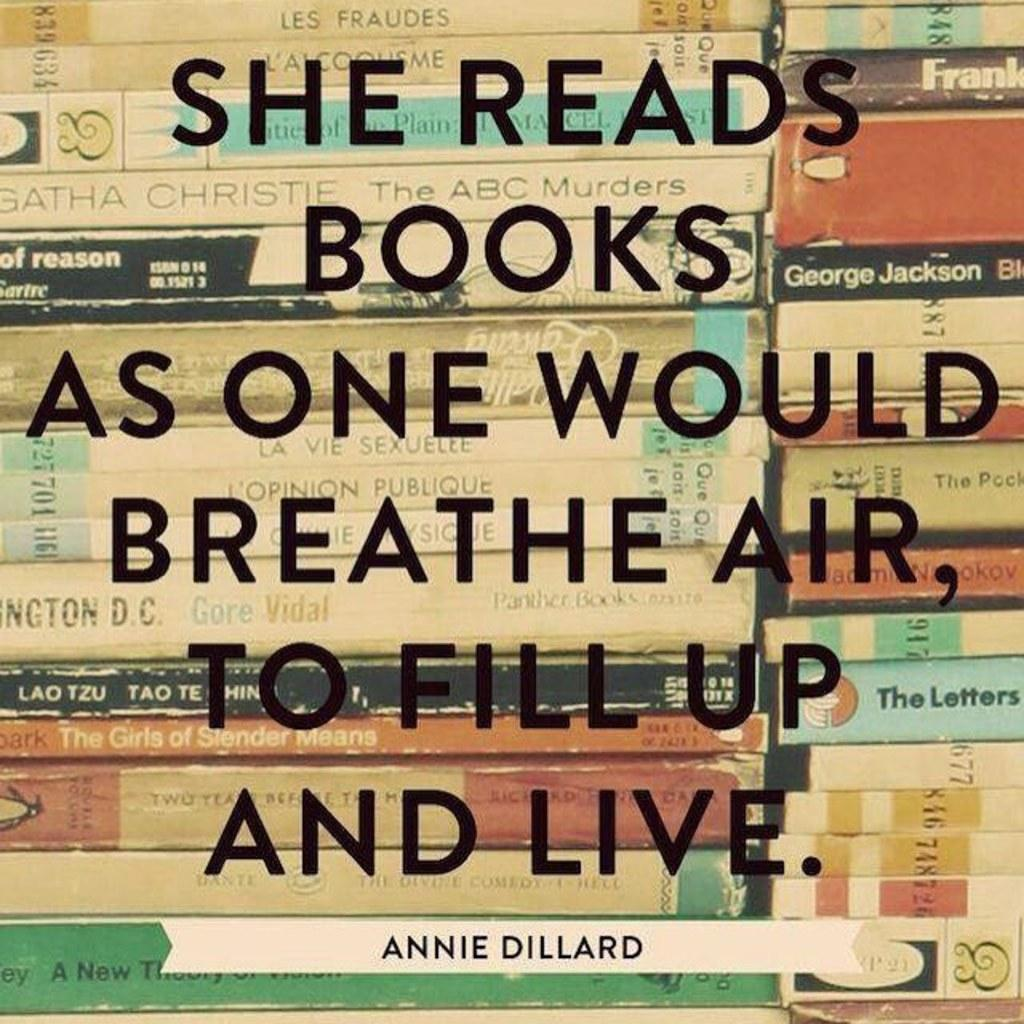<image>
Relay a brief, clear account of the picture shown. A quote about reading books by Annie Dillard 